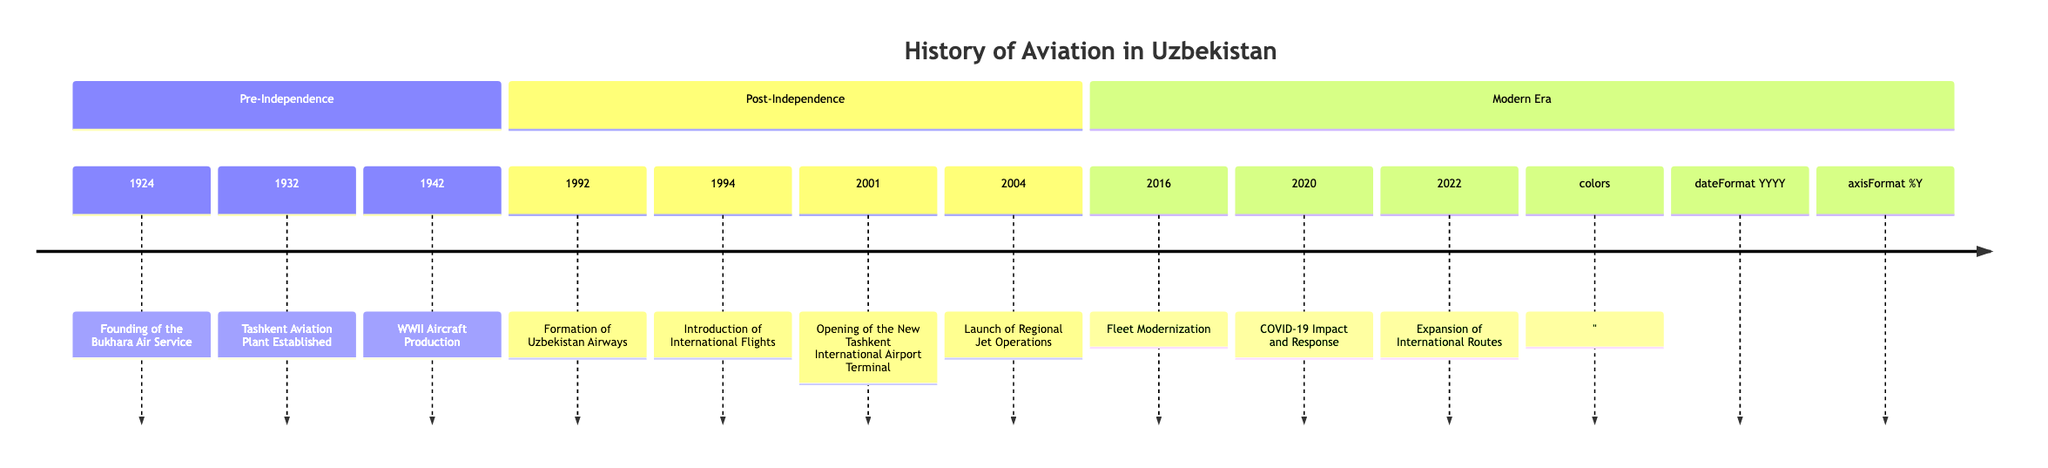What year was the Bukhara Air Service founded? The diagram lists "Founding of the Bukhara Air Service" in the year 1924 under the "Pre-Independence" section.
Answer: 1924 How many events occurred before 1992? The diagram shows three events listed under the "Pre-Independence" section (1924, 1932, 1942), and the years before 1992 are only those in this section.
Answer: 3 What significant event happened in 1994? The timeline shows "Introduction of International Flights" occurring in 1994 under the "Post-Independence" section.
Answer: Introduction of International Flights Which year saw the opening of a new terminal at Tashkent International Airport? The diagram states that "Opening of the New Tashkent International Airport Terminal" happened in 2001 within the "Post-Independence" section.
Answer: 2001 What is the last milestone listed in the diagram? The final event in the "Modern Era" section is "Expansion of International Routes" which is noted in 2022, thus making it the last milestone.
Answer: Expansion of International Routes Which major milestone in aviation occurred in 1942? According to the diagram, "WWII Aircraft Production" is the milestone from 1942 listed under the "Pre-Independence" section.
Answer: WWII Aircraft Production What is the primary focus of Uzbekistan Airways in 2020? The diagram notes the "COVID-19 Impact and Response," indicating that the focus shifted to cargo operations and repatriation flights during the pandemic.
Answer: COVID-19 Impact and Response How many milestones were recorded in the "Modern Era"? The diagram shows three milestones listed under the "Modern Era" section (2016, 2020, 2022), which can be counted.
Answer: 3 What year marks the establishment of Uzbekistan Airways? The establishment of Uzbekistan Airways is noted to have occurred in 1992 in the "Post-Independence" section of the diagram.
Answer: 1992 